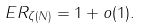<formula> <loc_0><loc_0><loc_500><loc_500>E R _ { \zeta ( N ) } = 1 + o ( 1 ) .</formula> 